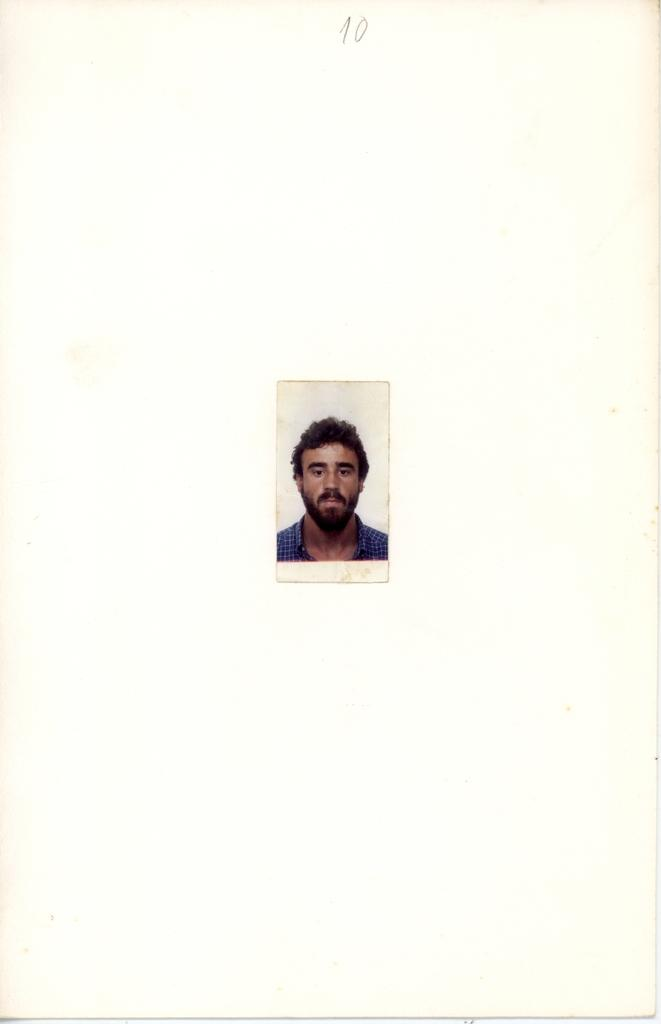What type of photo is in the image? There is a passport size photo in the image. What is the person in the photo wearing? The person in the photo is wearing a blue shirt. What color is the background of the photo? The background of the photo is white. What type of good-bye is being said in the image? There is no indication of anyone saying good-bye in the image, as it only features a passport size photo. 